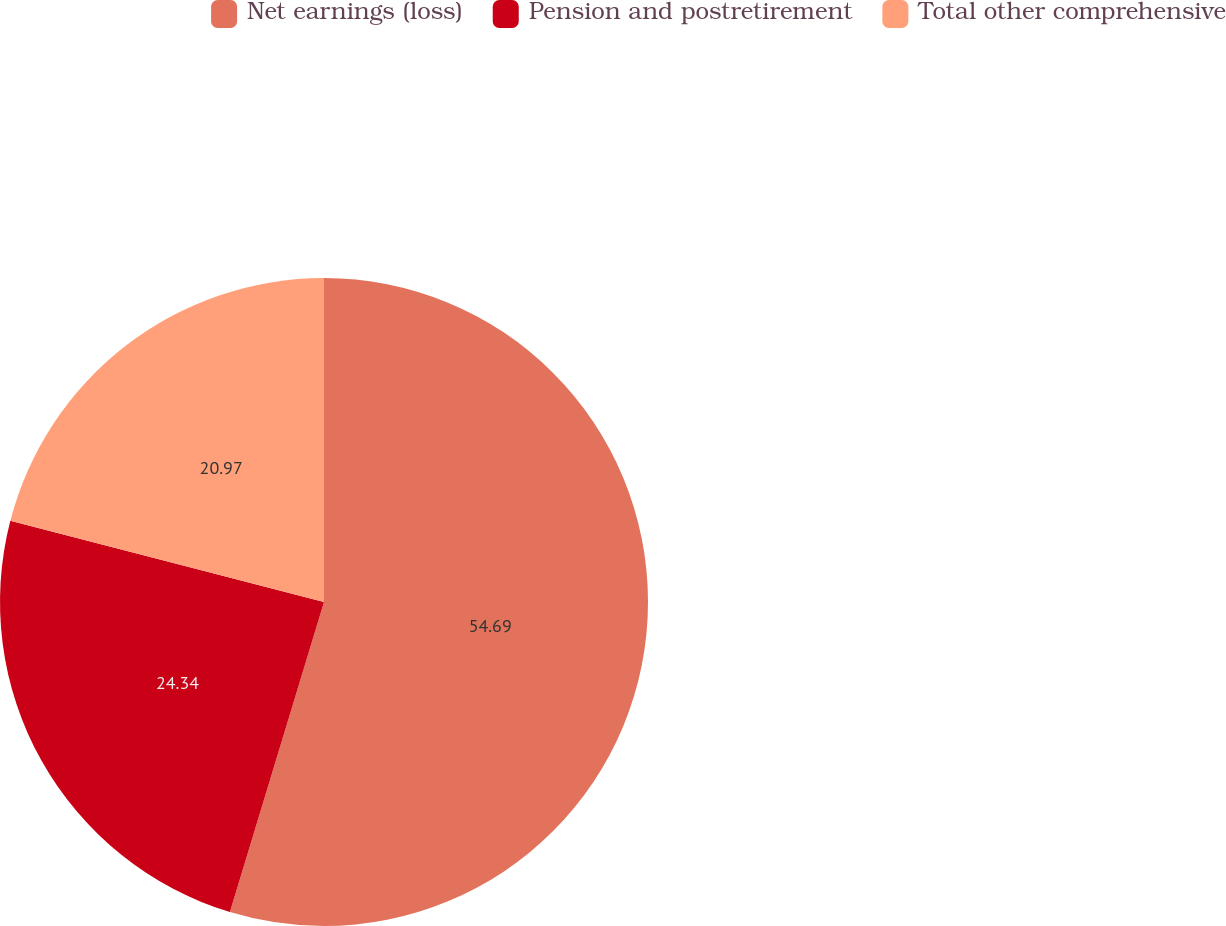<chart> <loc_0><loc_0><loc_500><loc_500><pie_chart><fcel>Net earnings (loss)<fcel>Pension and postretirement<fcel>Total other comprehensive<nl><fcel>54.69%<fcel>24.34%<fcel>20.97%<nl></chart> 